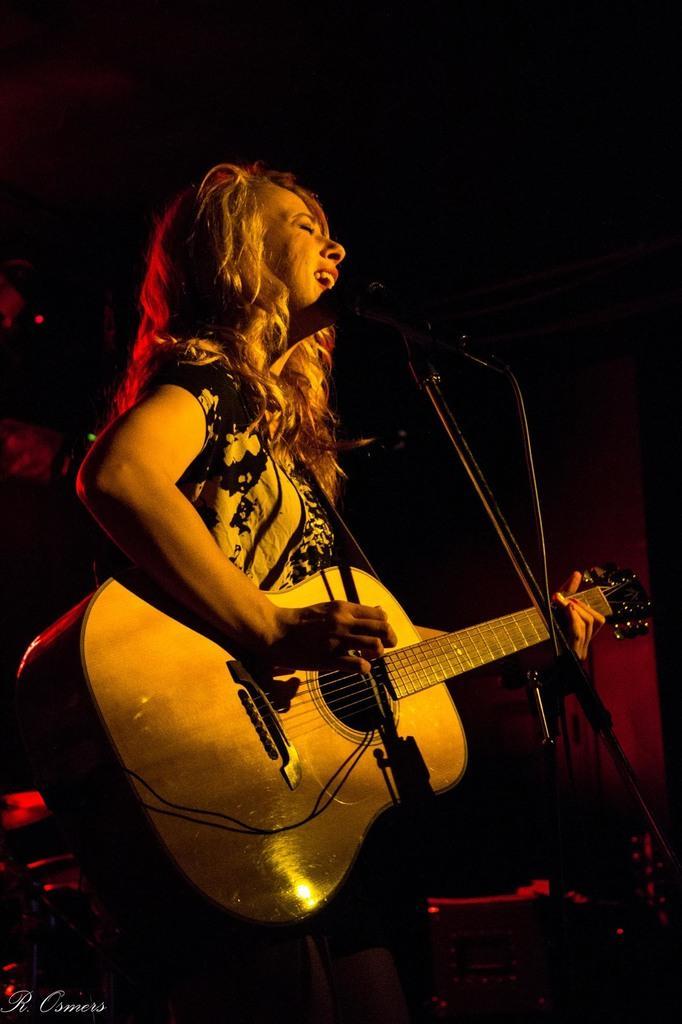In one or two sentences, can you explain what this image depicts? In this picture we can see a women who is standing in front of mike and playing guitar. 